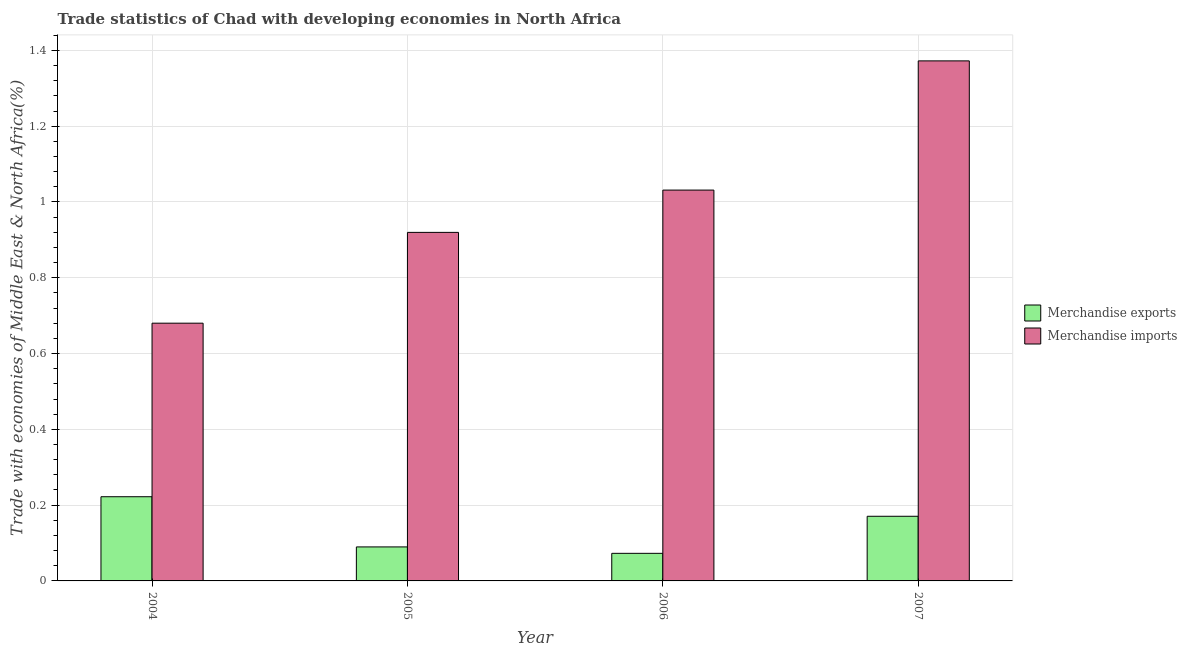Are the number of bars per tick equal to the number of legend labels?
Ensure brevity in your answer.  Yes. How many bars are there on the 1st tick from the left?
Offer a terse response. 2. What is the label of the 3rd group of bars from the left?
Offer a terse response. 2006. What is the merchandise exports in 2004?
Provide a short and direct response. 0.22. Across all years, what is the maximum merchandise exports?
Your response must be concise. 0.22. Across all years, what is the minimum merchandise imports?
Keep it short and to the point. 0.68. In which year was the merchandise exports minimum?
Give a very brief answer. 2006. What is the total merchandise imports in the graph?
Your response must be concise. 4. What is the difference between the merchandise exports in 2006 and that in 2007?
Offer a terse response. -0.1. What is the difference between the merchandise exports in 2006 and the merchandise imports in 2007?
Keep it short and to the point. -0.1. What is the average merchandise exports per year?
Provide a succinct answer. 0.14. In the year 2007, what is the difference between the merchandise imports and merchandise exports?
Your answer should be very brief. 0. In how many years, is the merchandise imports greater than 1.08 %?
Provide a short and direct response. 1. What is the ratio of the merchandise imports in 2004 to that in 2007?
Provide a short and direct response. 0.5. Is the difference between the merchandise exports in 2005 and 2007 greater than the difference between the merchandise imports in 2005 and 2007?
Offer a terse response. No. What is the difference between the highest and the second highest merchandise exports?
Offer a terse response. 0.05. What is the difference between the highest and the lowest merchandise imports?
Offer a terse response. 0.69. What does the 1st bar from the left in 2006 represents?
Provide a short and direct response. Merchandise exports. What does the 1st bar from the right in 2004 represents?
Ensure brevity in your answer.  Merchandise imports. How many bars are there?
Make the answer very short. 8. Are all the bars in the graph horizontal?
Your answer should be very brief. No. Are the values on the major ticks of Y-axis written in scientific E-notation?
Offer a very short reply. No. Does the graph contain any zero values?
Provide a succinct answer. No. Where does the legend appear in the graph?
Your answer should be compact. Center right. How many legend labels are there?
Provide a succinct answer. 2. How are the legend labels stacked?
Offer a very short reply. Vertical. What is the title of the graph?
Ensure brevity in your answer.  Trade statistics of Chad with developing economies in North Africa. Does "US$" appear as one of the legend labels in the graph?
Your response must be concise. No. What is the label or title of the Y-axis?
Provide a short and direct response. Trade with economies of Middle East & North Africa(%). What is the Trade with economies of Middle East & North Africa(%) of Merchandise exports in 2004?
Offer a very short reply. 0.22. What is the Trade with economies of Middle East & North Africa(%) of Merchandise imports in 2004?
Provide a short and direct response. 0.68. What is the Trade with economies of Middle East & North Africa(%) in Merchandise exports in 2005?
Offer a very short reply. 0.09. What is the Trade with economies of Middle East & North Africa(%) in Merchandise imports in 2005?
Provide a short and direct response. 0.92. What is the Trade with economies of Middle East & North Africa(%) of Merchandise exports in 2006?
Offer a very short reply. 0.07. What is the Trade with economies of Middle East & North Africa(%) of Merchandise imports in 2006?
Your answer should be compact. 1.03. What is the Trade with economies of Middle East & North Africa(%) of Merchandise exports in 2007?
Offer a very short reply. 0.17. What is the Trade with economies of Middle East & North Africa(%) of Merchandise imports in 2007?
Ensure brevity in your answer.  1.37. Across all years, what is the maximum Trade with economies of Middle East & North Africa(%) in Merchandise exports?
Provide a succinct answer. 0.22. Across all years, what is the maximum Trade with economies of Middle East & North Africa(%) in Merchandise imports?
Offer a very short reply. 1.37. Across all years, what is the minimum Trade with economies of Middle East & North Africa(%) in Merchandise exports?
Your response must be concise. 0.07. Across all years, what is the minimum Trade with economies of Middle East & North Africa(%) in Merchandise imports?
Offer a very short reply. 0.68. What is the total Trade with economies of Middle East & North Africa(%) in Merchandise exports in the graph?
Your response must be concise. 0.56. What is the total Trade with economies of Middle East & North Africa(%) of Merchandise imports in the graph?
Provide a succinct answer. 4. What is the difference between the Trade with economies of Middle East & North Africa(%) in Merchandise exports in 2004 and that in 2005?
Offer a very short reply. 0.13. What is the difference between the Trade with economies of Middle East & North Africa(%) of Merchandise imports in 2004 and that in 2005?
Provide a succinct answer. -0.24. What is the difference between the Trade with economies of Middle East & North Africa(%) in Merchandise exports in 2004 and that in 2006?
Keep it short and to the point. 0.15. What is the difference between the Trade with economies of Middle East & North Africa(%) in Merchandise imports in 2004 and that in 2006?
Your response must be concise. -0.35. What is the difference between the Trade with economies of Middle East & North Africa(%) in Merchandise exports in 2004 and that in 2007?
Provide a succinct answer. 0.05. What is the difference between the Trade with economies of Middle East & North Africa(%) of Merchandise imports in 2004 and that in 2007?
Give a very brief answer. -0.69. What is the difference between the Trade with economies of Middle East & North Africa(%) in Merchandise exports in 2005 and that in 2006?
Your answer should be very brief. 0.02. What is the difference between the Trade with economies of Middle East & North Africa(%) of Merchandise imports in 2005 and that in 2006?
Provide a short and direct response. -0.11. What is the difference between the Trade with economies of Middle East & North Africa(%) in Merchandise exports in 2005 and that in 2007?
Your answer should be very brief. -0.08. What is the difference between the Trade with economies of Middle East & North Africa(%) in Merchandise imports in 2005 and that in 2007?
Offer a very short reply. -0.45. What is the difference between the Trade with economies of Middle East & North Africa(%) in Merchandise exports in 2006 and that in 2007?
Provide a short and direct response. -0.1. What is the difference between the Trade with economies of Middle East & North Africa(%) of Merchandise imports in 2006 and that in 2007?
Your answer should be very brief. -0.34. What is the difference between the Trade with economies of Middle East & North Africa(%) in Merchandise exports in 2004 and the Trade with economies of Middle East & North Africa(%) in Merchandise imports in 2005?
Offer a terse response. -0.7. What is the difference between the Trade with economies of Middle East & North Africa(%) of Merchandise exports in 2004 and the Trade with economies of Middle East & North Africa(%) of Merchandise imports in 2006?
Make the answer very short. -0.81. What is the difference between the Trade with economies of Middle East & North Africa(%) in Merchandise exports in 2004 and the Trade with economies of Middle East & North Africa(%) in Merchandise imports in 2007?
Provide a succinct answer. -1.15. What is the difference between the Trade with economies of Middle East & North Africa(%) of Merchandise exports in 2005 and the Trade with economies of Middle East & North Africa(%) of Merchandise imports in 2006?
Keep it short and to the point. -0.94. What is the difference between the Trade with economies of Middle East & North Africa(%) of Merchandise exports in 2005 and the Trade with economies of Middle East & North Africa(%) of Merchandise imports in 2007?
Your answer should be compact. -1.28. What is the difference between the Trade with economies of Middle East & North Africa(%) of Merchandise exports in 2006 and the Trade with economies of Middle East & North Africa(%) of Merchandise imports in 2007?
Keep it short and to the point. -1.3. What is the average Trade with economies of Middle East & North Africa(%) of Merchandise exports per year?
Provide a short and direct response. 0.14. In the year 2004, what is the difference between the Trade with economies of Middle East & North Africa(%) of Merchandise exports and Trade with economies of Middle East & North Africa(%) of Merchandise imports?
Your answer should be very brief. -0.46. In the year 2005, what is the difference between the Trade with economies of Middle East & North Africa(%) of Merchandise exports and Trade with economies of Middle East & North Africa(%) of Merchandise imports?
Provide a succinct answer. -0.83. In the year 2006, what is the difference between the Trade with economies of Middle East & North Africa(%) of Merchandise exports and Trade with economies of Middle East & North Africa(%) of Merchandise imports?
Provide a short and direct response. -0.96. In the year 2007, what is the difference between the Trade with economies of Middle East & North Africa(%) in Merchandise exports and Trade with economies of Middle East & North Africa(%) in Merchandise imports?
Give a very brief answer. -1.2. What is the ratio of the Trade with economies of Middle East & North Africa(%) in Merchandise exports in 2004 to that in 2005?
Offer a terse response. 2.48. What is the ratio of the Trade with economies of Middle East & North Africa(%) of Merchandise imports in 2004 to that in 2005?
Give a very brief answer. 0.74. What is the ratio of the Trade with economies of Middle East & North Africa(%) in Merchandise exports in 2004 to that in 2006?
Offer a very short reply. 3.05. What is the ratio of the Trade with economies of Middle East & North Africa(%) of Merchandise imports in 2004 to that in 2006?
Ensure brevity in your answer.  0.66. What is the ratio of the Trade with economies of Middle East & North Africa(%) in Merchandise exports in 2004 to that in 2007?
Make the answer very short. 1.3. What is the ratio of the Trade with economies of Middle East & North Africa(%) of Merchandise imports in 2004 to that in 2007?
Provide a short and direct response. 0.5. What is the ratio of the Trade with economies of Middle East & North Africa(%) in Merchandise exports in 2005 to that in 2006?
Make the answer very short. 1.23. What is the ratio of the Trade with economies of Middle East & North Africa(%) of Merchandise imports in 2005 to that in 2006?
Keep it short and to the point. 0.89. What is the ratio of the Trade with economies of Middle East & North Africa(%) in Merchandise exports in 2005 to that in 2007?
Offer a very short reply. 0.53. What is the ratio of the Trade with economies of Middle East & North Africa(%) in Merchandise imports in 2005 to that in 2007?
Give a very brief answer. 0.67. What is the ratio of the Trade with economies of Middle East & North Africa(%) of Merchandise exports in 2006 to that in 2007?
Provide a short and direct response. 0.43. What is the ratio of the Trade with economies of Middle East & North Africa(%) in Merchandise imports in 2006 to that in 2007?
Your response must be concise. 0.75. What is the difference between the highest and the second highest Trade with economies of Middle East & North Africa(%) of Merchandise exports?
Give a very brief answer. 0.05. What is the difference between the highest and the second highest Trade with economies of Middle East & North Africa(%) of Merchandise imports?
Offer a terse response. 0.34. What is the difference between the highest and the lowest Trade with economies of Middle East & North Africa(%) in Merchandise exports?
Ensure brevity in your answer.  0.15. What is the difference between the highest and the lowest Trade with economies of Middle East & North Africa(%) in Merchandise imports?
Ensure brevity in your answer.  0.69. 